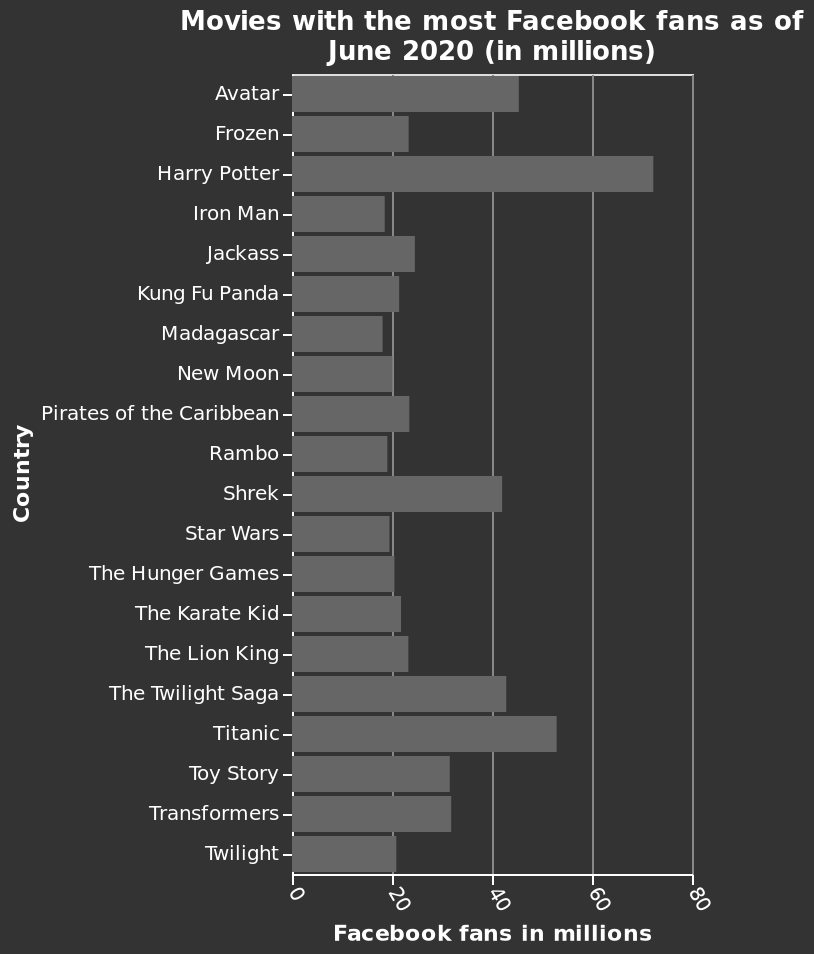<image>
What is the range of the x-axis on the bar chart? The range of the x-axis on the bar chart is from 0 to 80 million, representing the number of Facebook fans in millions. 